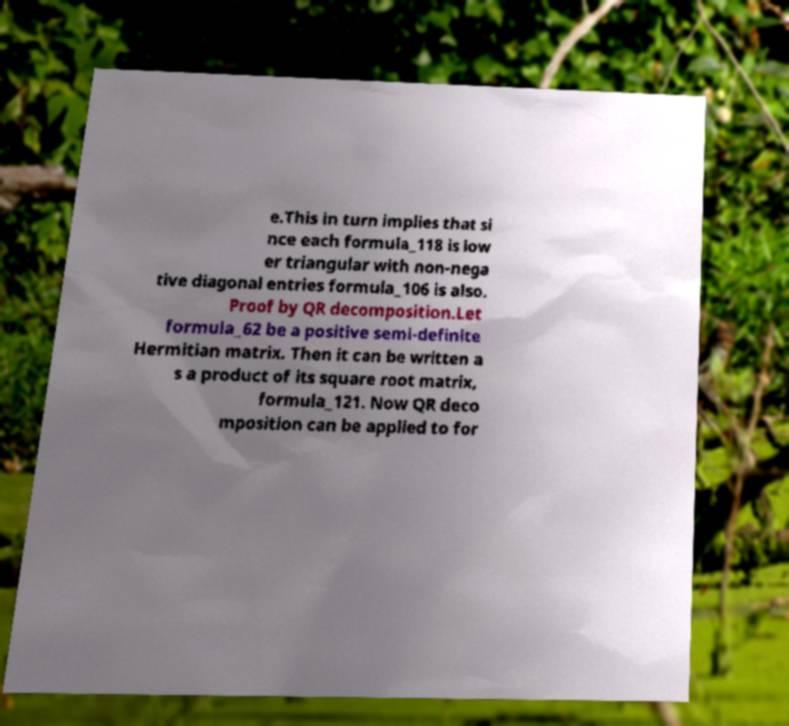I need the written content from this picture converted into text. Can you do that? e.This in turn implies that si nce each formula_118 is low er triangular with non-nega tive diagonal entries formula_106 is also. Proof by QR decomposition.Let formula_62 be a positive semi-definite Hermitian matrix. Then it can be written a s a product of its square root matrix, formula_121. Now QR deco mposition can be applied to for 